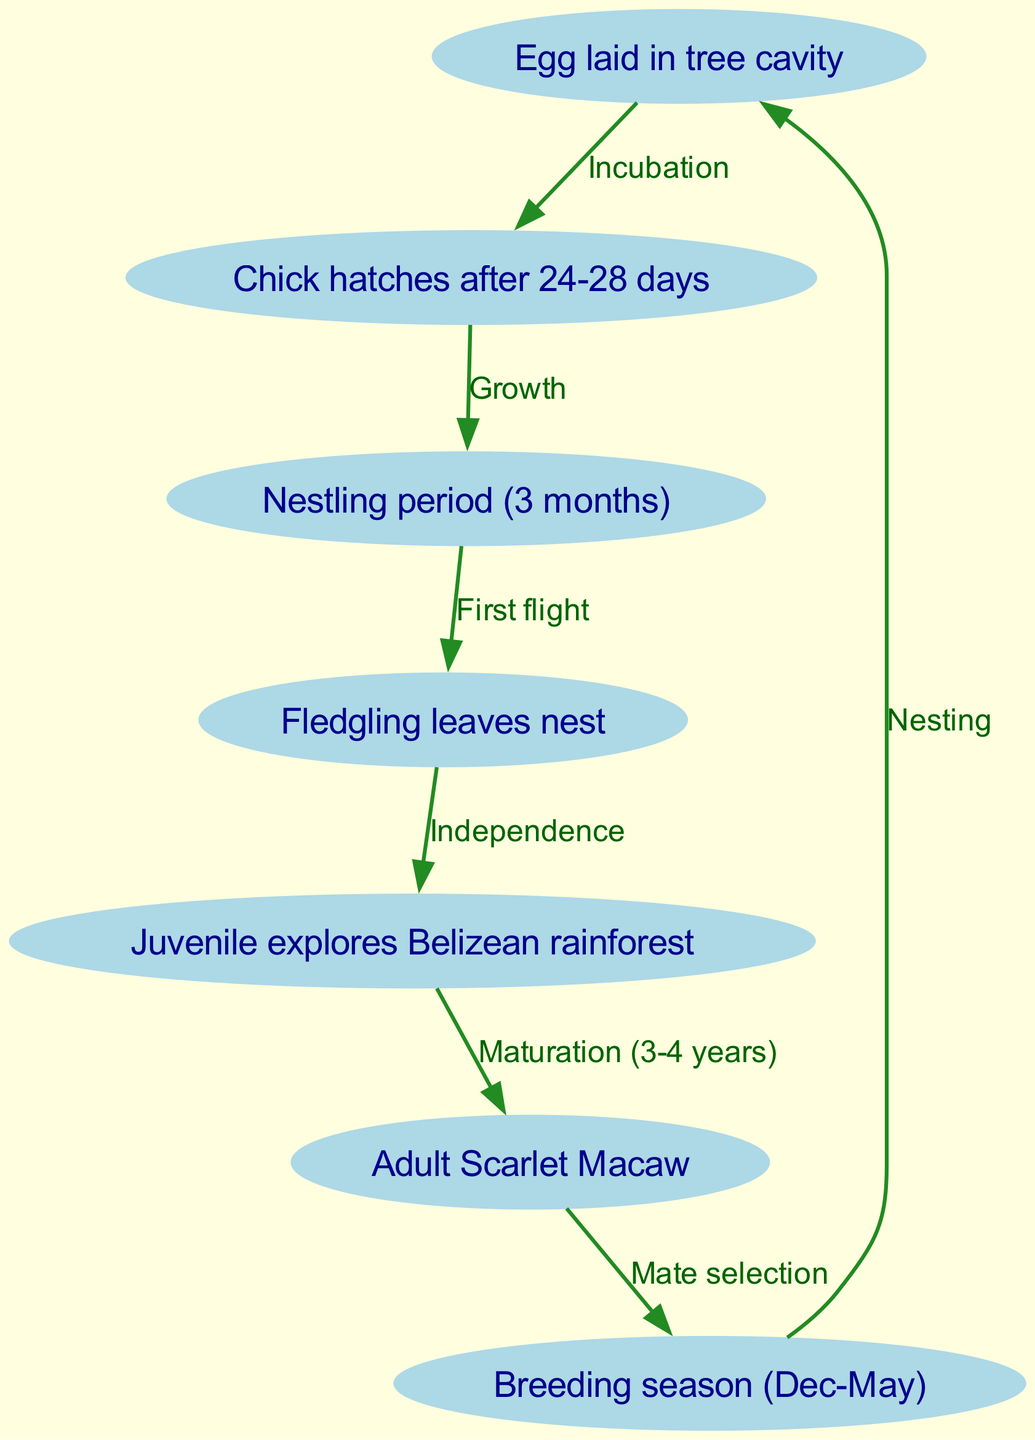What is the first stage in the lifecycle of a Scarlet Macaw? The first node in the diagram is "Egg laid in tree cavity", which represents the initial stage of the lifecycle.
Answer: Egg laid in tree cavity How long does it take for a chick to hatch after the egg is laid? The edge from the "egg" node to the "hatch" node indicates that the incubation period lasts for 24-28 days.
Answer: 24-28 days What is the duration of the nestling period? The "nestling" node states its duration is 3 months, indicating how long the chick remains in this stage.
Answer: 3 months At what stage does the Scarlet Macaw gain independence from the nest? The flow from "fledgling" to "juvenile" suggests that the fledgling leaves the nest and becomes independent in the next stage.
Answer: Fledgling leaves nest How long does it take for a juvenile Scarlet Macaw to mature into an adult? The transition from "juvenile" to "adult" indicates that maturation occurs over a span of 3-4 years.
Answer: 3-4 years What season is designated for breeding in Scarlet Macaws? The "breeding" node notes that the breeding season spans from December to May, marking the specific time for reproduction.
Answer: December to May How many total nodes are present in the flowchart? By counting all the nodes listed, including "egg", "hatch", "nestling", "fledgling", "juvenile", "adult", and "breeding", we find there are 7 nodes.
Answer: 7 What process follows the nesting in the lifecycle of a Scarlet Macaw? The flow from "breeding" back to "egg" indicates that after the breeding season and nesting, the process continues with the laying of eggs.
Answer: Nesting Which stage comes directly after the "nestling" stage? The diagram shows a direct connection from "nestling" to "fledgling", meaning that fledgling is the stage that follows nestling.
Answer: Fledgling 